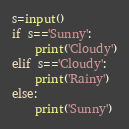<code> <loc_0><loc_0><loc_500><loc_500><_Python_>s=input()
if s=='Sunny':
    print('Cloudy')
elif s=='Cloudy':
    print('Rainy')
else:
    print('Sunny')

</code> 